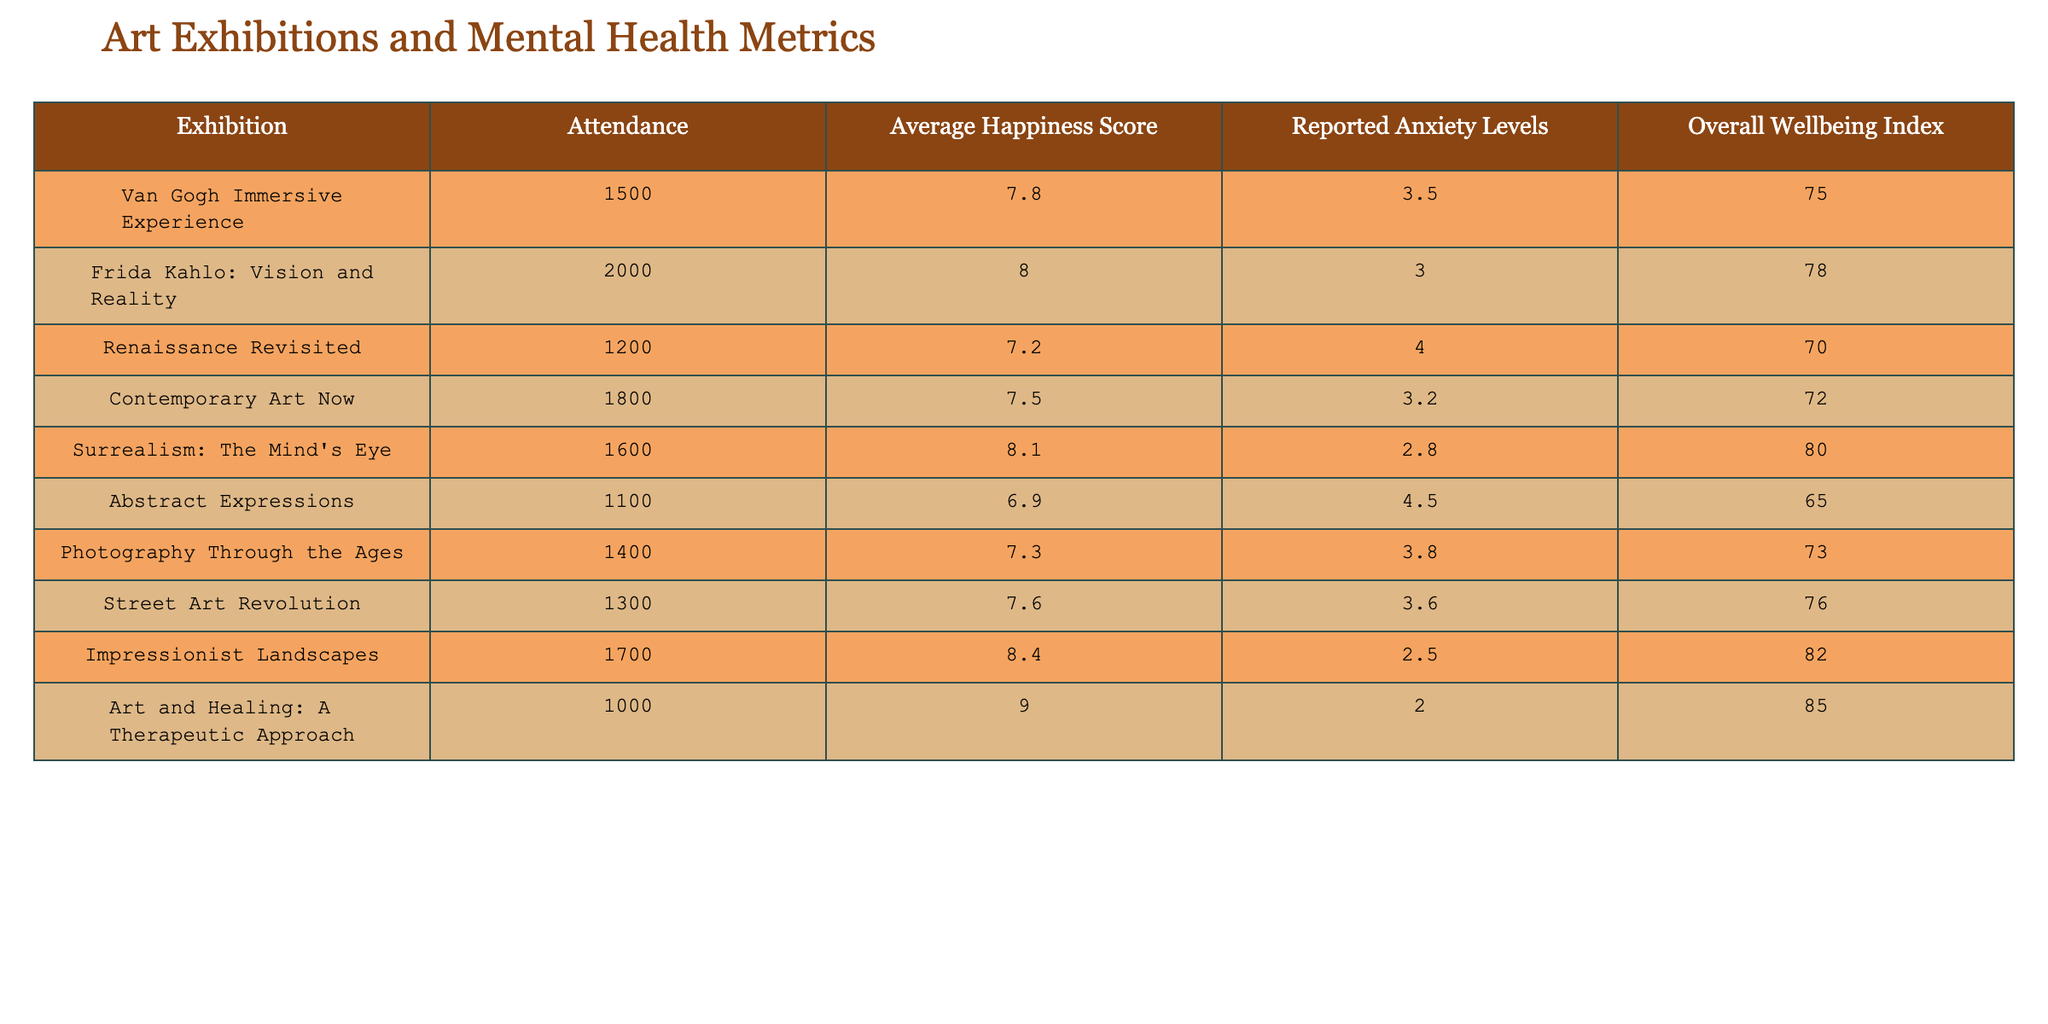What is the attendance for the "Art and Healing: A Therapeutic Approach" exhibition? The attendance for this specific exhibition is listed directly in the table under the "Attendance" column, which states 1000.
Answer: 1000 Which exhibition had the highest Average Happiness Score? By comparing the average happiness scores for all exhibitions, "Art and Healing: A Therapeutic Approach" has the highest score at 9.0.
Answer: Art and Healing: A Therapeutic Approach What is the difference between the Average Happiness Score of the "Impressionist Landscapes" and "Abstract Expressions"? The Average Happiness Score for "Impressionist Landscapes" is 8.4, and for "Abstract Expressions," it is 6.9. The difference is 8.4 - 6.9 = 1.5.
Answer: 1.5 Is the Reported Anxiety Level for "Surrealism: The Mind's Eye" lower than that for "Contemporary Art Now"? "Surrealism: The Mind's Eye" has a Reported Anxiety Level of 2.8, whereas "Contemporary Art Now" has 3.2. Since 2.8 is less than 3.2, the answer is yes.
Answer: Yes What is the total Attendance for all exhibitions combined? To find the total attendance, we sum the attendance for all exhibitions: 1500 + 2000 + 1200 + 1800 + 1600 + 1100 + 1400 + 1300 + 1700 + 1000 = 15700.
Answer: 15700 Which exhibition had the highest Reported Anxiety Level and what was it? By examining the Reported Anxiety Levels, "Abstract Expressions" has the highest level at 4.5.
Answer: Abstract Expressions, 4.5 What is the average Overall Wellbeing Index across all exhibitions? First, we sum the Overall Wellbeing Index values: 75 + 78 + 70 + 72 + 80 + 65 + 73 + 76 + 82 + 85 = 785. There are 10 exhibitions, so the average is 785 / 10 = 78.5.
Answer: 78.5 Did more than 1,500 people attend the "Frida Kahlo: Vision and Reality" exhibition? The attendance for this exhibition was 2000, which is greater than 1500, so the answer is yes.
Answer: Yes How does the Average Happiness Score of exhibitions with attendance greater than 1500 compare to those with lower attendance? First, we identify the exhibitions with attendance over 1500: "Frida Kahlo," "Contemporary Art Now," "Surrealism," "Impressionist Landscapes," and "Art and Healing." Their scores are 8.0, 7.5, 8.1, 8.4, and 9.0. The average of these scores is (8.0 + 7.5 + 8.1 + 8.4 + 9.0) / 5 = 8.20. For those under 1500: "Van Gogh," "Renaissance," "Abstract Expressions," "Photography," and "Street Art," with scores of 7.8, 7.2, 6.9, 7.3, and 7.6, their average is (7.8 + 7.2 + 6.9 + 7.3 + 7.6) / 5 = 7.36. The difference shows that exhibitions over 1500 have a higher Average Happiness Score.
Answer: Higher Average Happiness Score for those over 1500 